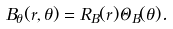<formula> <loc_0><loc_0><loc_500><loc_500>B _ { \theta } ( r , \theta ) = R _ { B } ( r ) \Theta _ { B } ( \theta ) .</formula> 